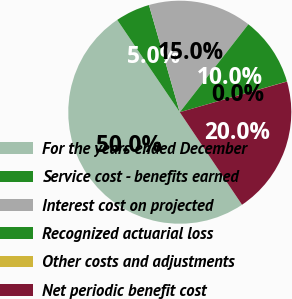<chart> <loc_0><loc_0><loc_500><loc_500><pie_chart><fcel>For the years ended December<fcel>Service cost - benefits earned<fcel>Interest cost on projected<fcel>Recognized actuarial loss<fcel>Other costs and adjustments<fcel>Net periodic benefit cost<nl><fcel>49.95%<fcel>5.02%<fcel>15.0%<fcel>10.01%<fcel>0.02%<fcel>20.0%<nl></chart> 